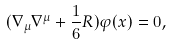Convert formula to latex. <formula><loc_0><loc_0><loc_500><loc_500>( \nabla _ { \mu } \nabla ^ { \mu } + \frac { 1 } { 6 } R ) \varphi ( x ) = 0 ,</formula> 